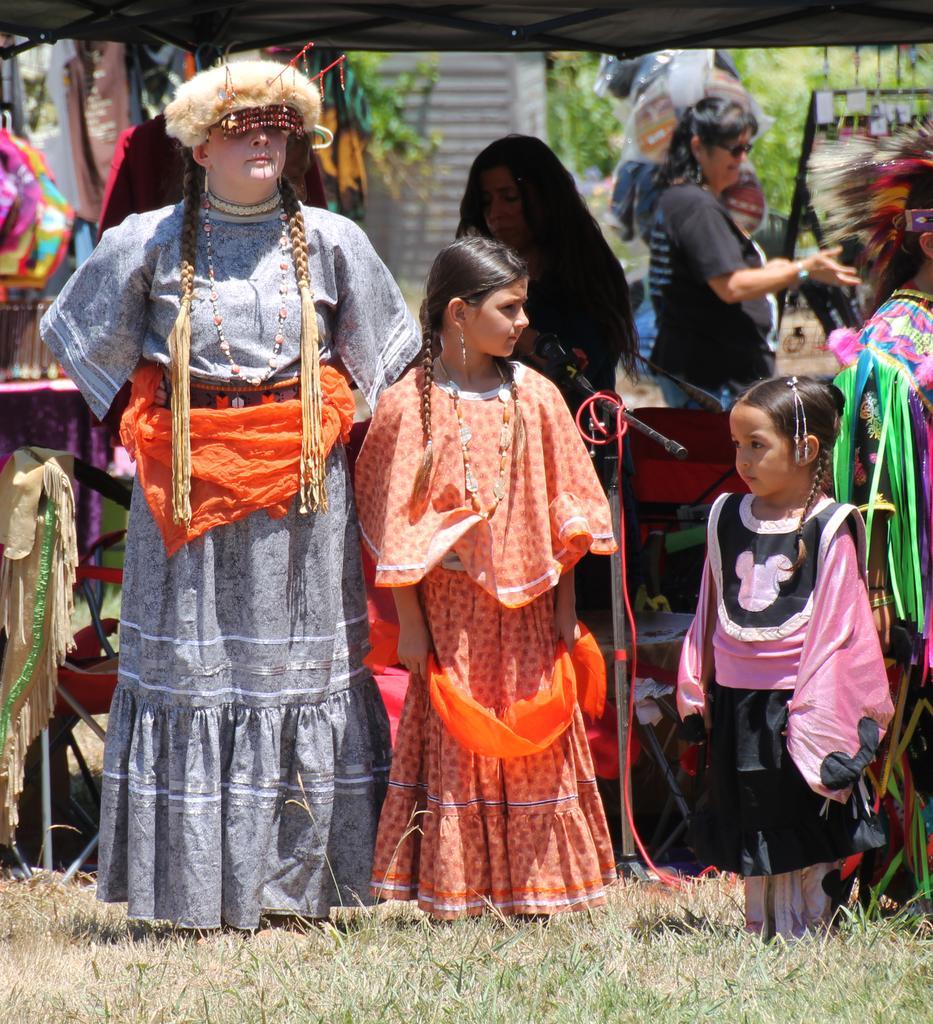Please provide a concise description of this image. In the center of the image there are persons standing on the ground. In the background there is a mic, tub, clothes, women, persons, trees and wall. 